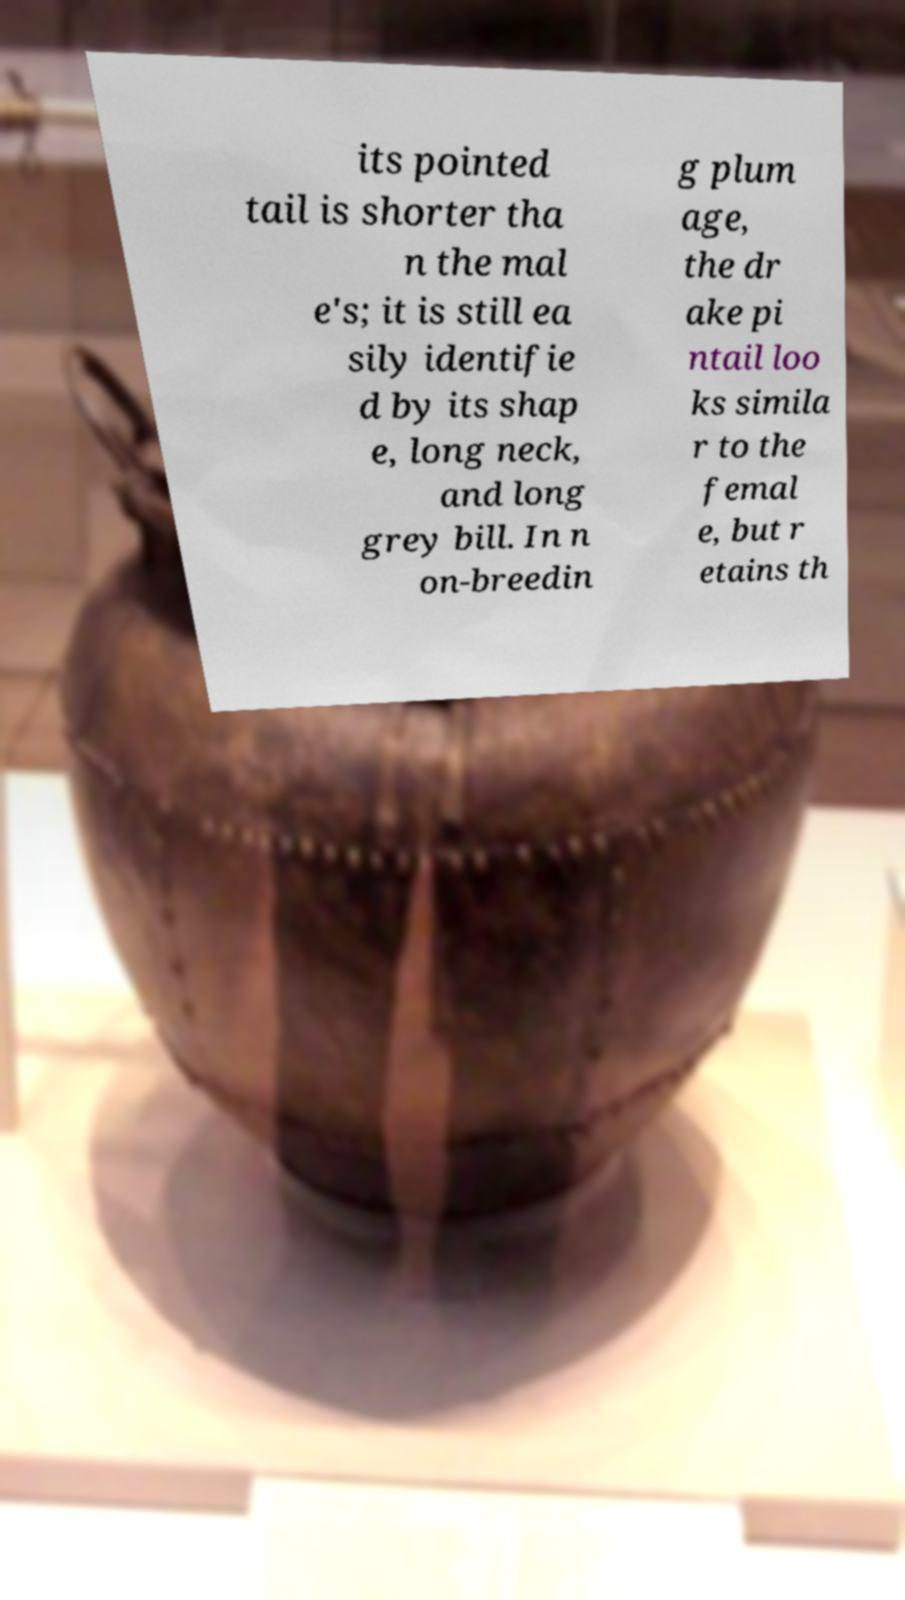For documentation purposes, I need the text within this image transcribed. Could you provide that? its pointed tail is shorter tha n the mal e's; it is still ea sily identifie d by its shap e, long neck, and long grey bill. In n on-breedin g plum age, the dr ake pi ntail loo ks simila r to the femal e, but r etains th 